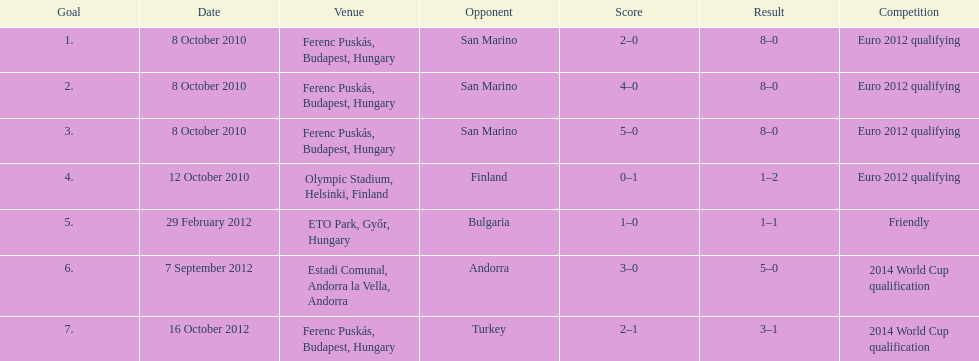In addition to euro 2012 qualifying, at which other level of play did szalai score all but one of his international goals? 2014 World Cup qualification. 